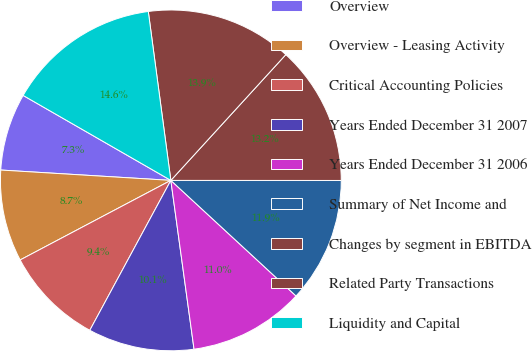Convert chart to OTSL. <chart><loc_0><loc_0><loc_500><loc_500><pie_chart><fcel>Overview<fcel>Overview - Leasing Activity<fcel>Critical Accounting Policies<fcel>Years Ended December 31 2007<fcel>Years Ended December 31 2006<fcel>Summary of Net Income and<fcel>Changes by segment in EBITDA<fcel>Related Party Transactions<fcel>Liquidity and Capital<nl><fcel>7.34%<fcel>8.7%<fcel>9.38%<fcel>10.06%<fcel>10.96%<fcel>11.86%<fcel>13.22%<fcel>13.9%<fcel>14.58%<nl></chart> 